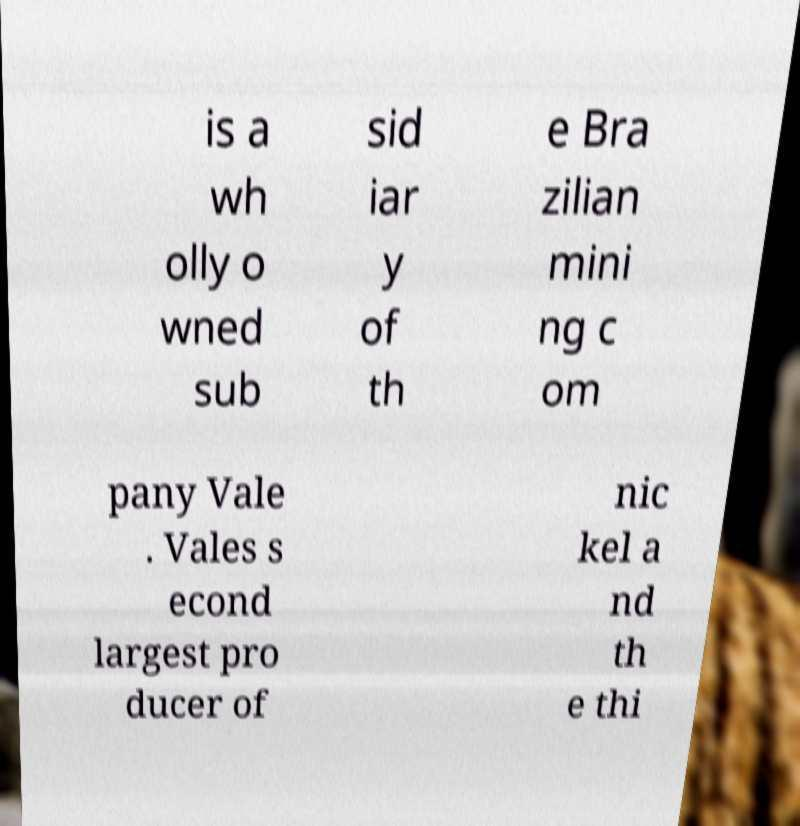I need the written content from this picture converted into text. Can you do that? is a wh olly o wned sub sid iar y of th e Bra zilian mini ng c om pany Vale . Vales s econd largest pro ducer of nic kel a nd th e thi 